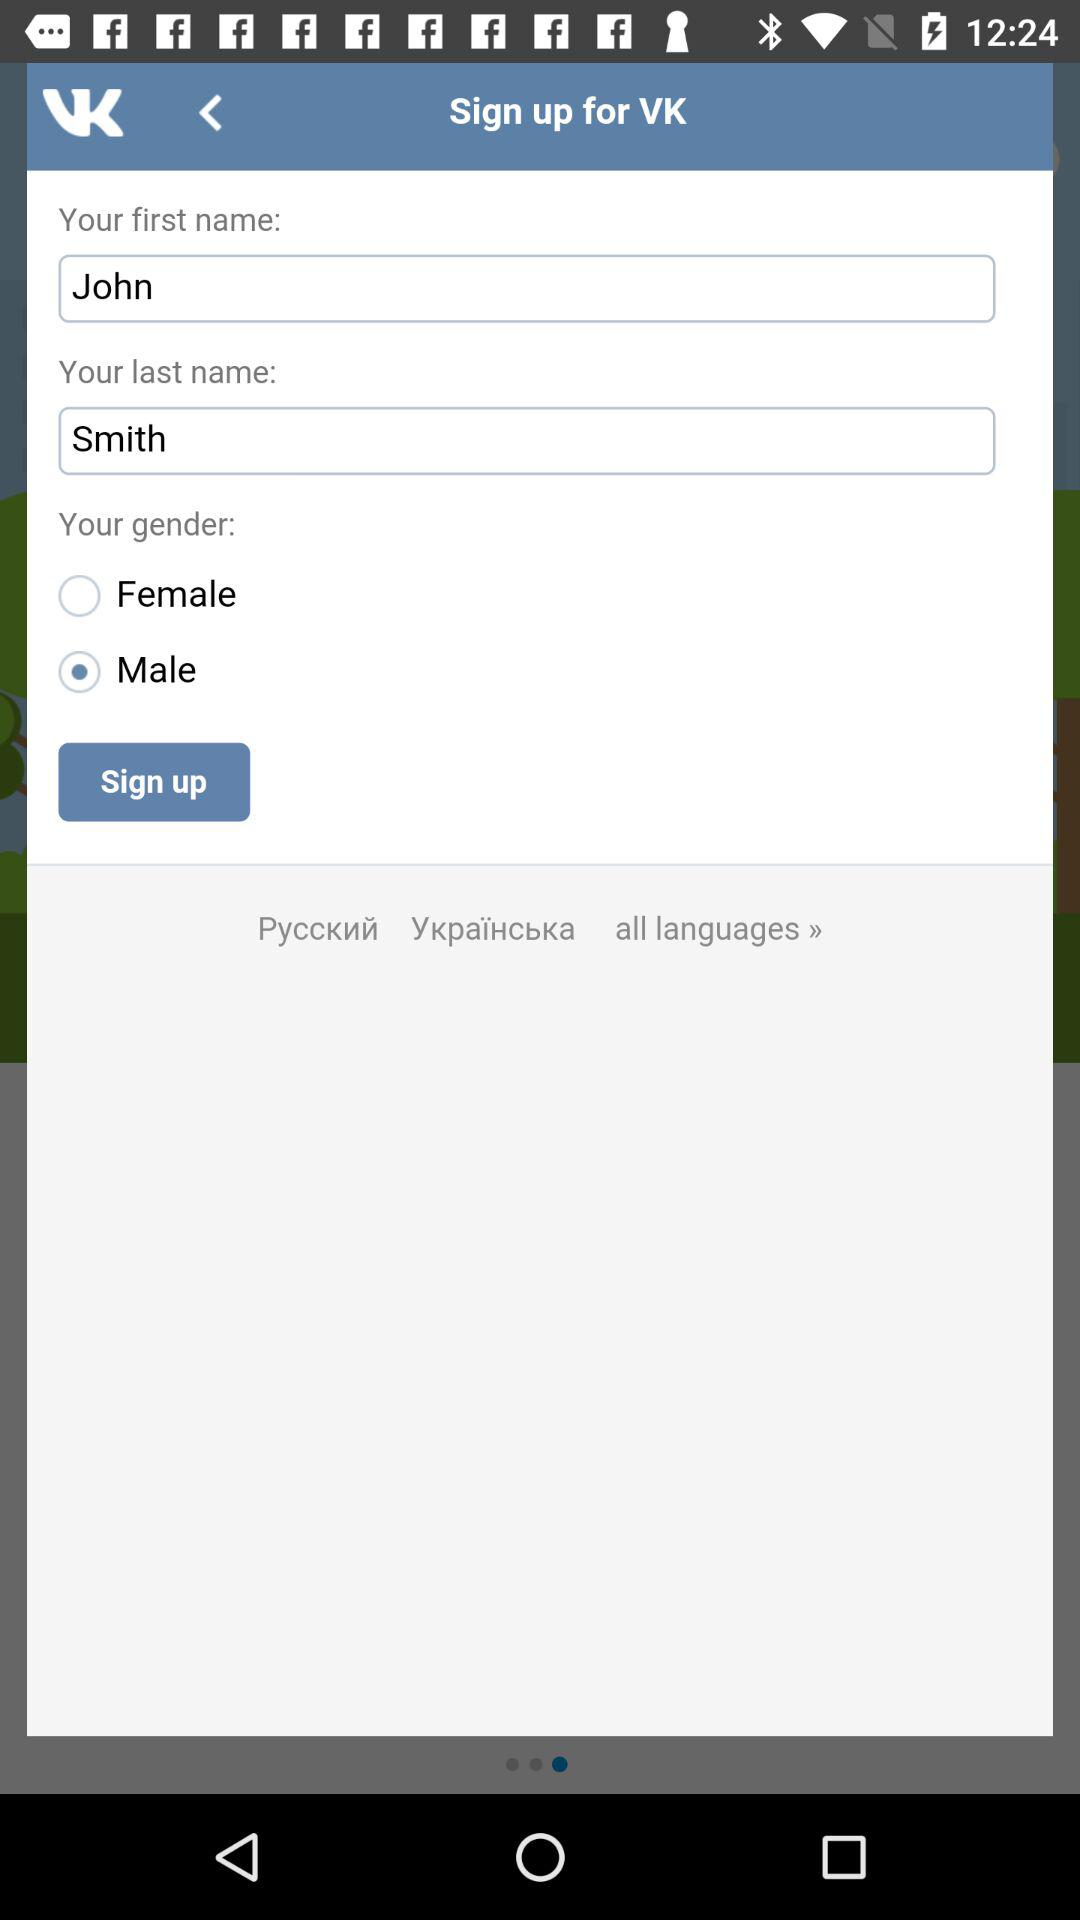What is the user's last name? The user's last name is Smith. 